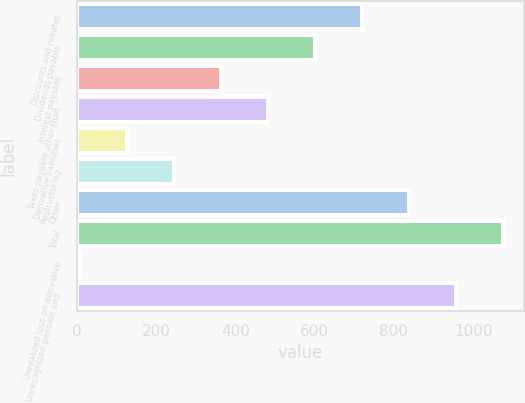<chart> <loc_0><loc_0><loc_500><loc_500><bar_chart><fcel>Discounts and rebates<fcel>Dividends payable<fcel>Interest payable<fcel>Taxes payable other than<fcel>Derivative liabilities<fcel>Restructuring<fcel>Other<fcel>Total<fcel>Unrealized loss on derivative<fcel>Unrecognized pension and<nl><fcel>719.2<fcel>600.75<fcel>363.85<fcel>482.3<fcel>126.95<fcel>245.4<fcel>837.65<fcel>1074.55<fcel>8.5<fcel>956.1<nl></chart> 